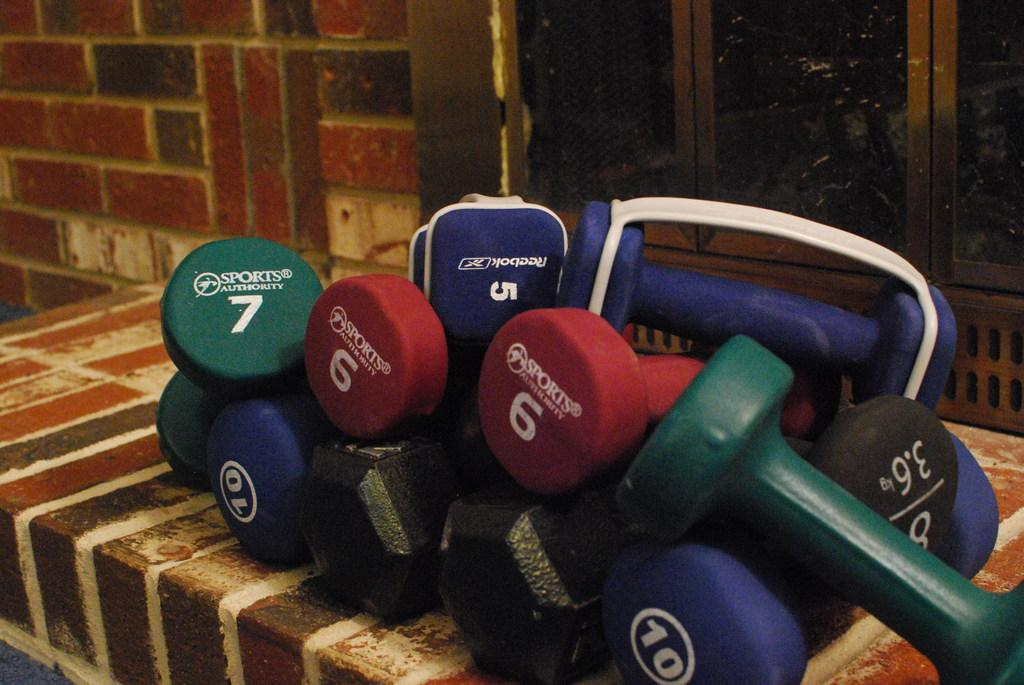What is the main subject in the center of the image? There are colorful dumbbells in the center of the image. What can be seen in the background of the image? There are windows in the background of the image. What type of instrument is being played by the giraffe in the image? There is no giraffe or instrument present in the image. 